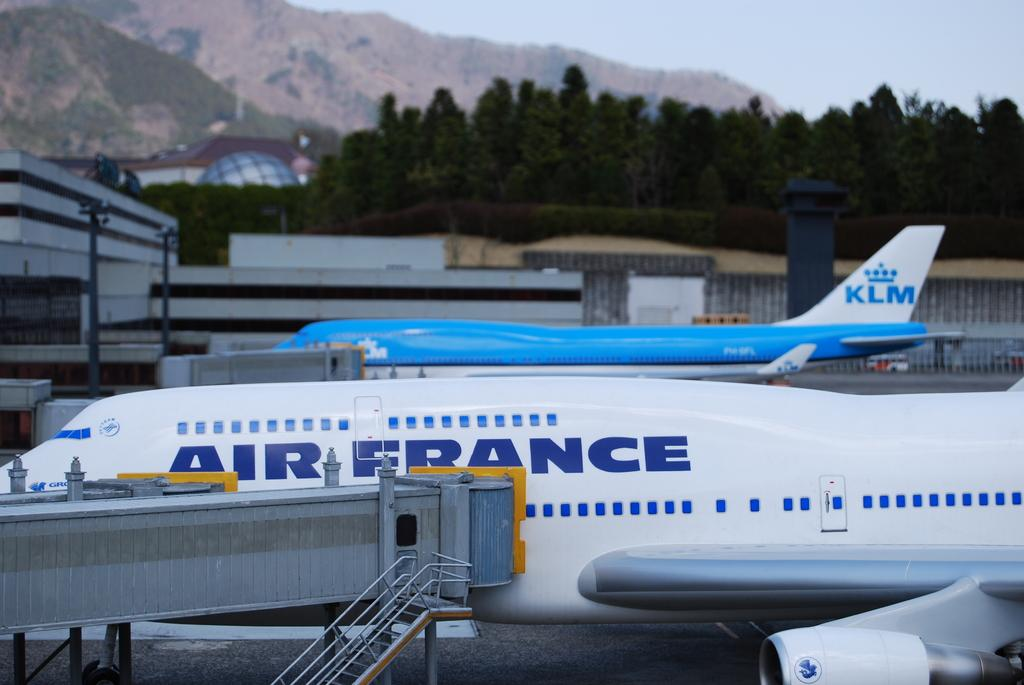What is located in the foreground of the image? There are stairs and an airplane in the foreground of the image. Can you describe the airplane in the foreground? Yes, there is another airplane in the background of the image. What can be seen in the background of the image? There are buildings, trees, a vehicle on the road, mountains, and the sky visible in the background of the image. What type of marble is being used to construct the shop in the image? There is no shop present in the image, and therefore no marble can be observed. 